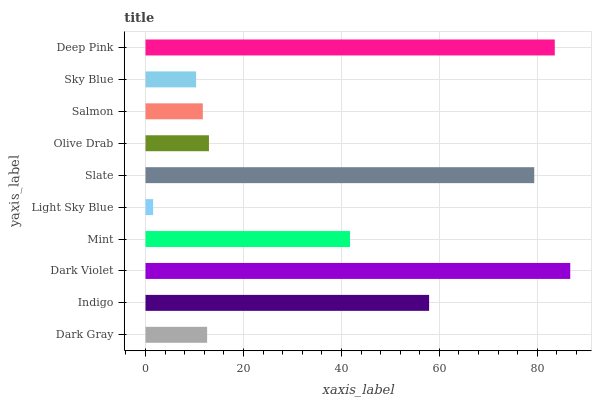Is Light Sky Blue the minimum?
Answer yes or no. Yes. Is Dark Violet the maximum?
Answer yes or no. Yes. Is Indigo the minimum?
Answer yes or no. No. Is Indigo the maximum?
Answer yes or no. No. Is Indigo greater than Dark Gray?
Answer yes or no. Yes. Is Dark Gray less than Indigo?
Answer yes or no. Yes. Is Dark Gray greater than Indigo?
Answer yes or no. No. Is Indigo less than Dark Gray?
Answer yes or no. No. Is Mint the high median?
Answer yes or no. Yes. Is Olive Drab the low median?
Answer yes or no. Yes. Is Dark Violet the high median?
Answer yes or no. No. Is Light Sky Blue the low median?
Answer yes or no. No. 